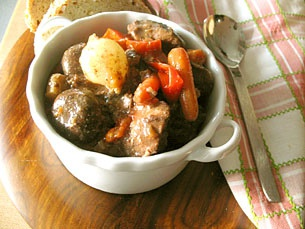Describe the objects in this image and their specific colors. I can see bowl in darkgray, ivory, black, tan, and maroon tones, spoon in darkgray and olive tones, carrot in darkgray, brown, maroon, red, and orange tones, carrot in darkgray, red, brown, and maroon tones, and carrot in darkgray, red, orange, and brown tones in this image. 